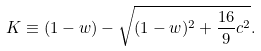<formula> <loc_0><loc_0><loc_500><loc_500>K \equiv ( 1 - w ) - \sqrt { ( 1 - w ) ^ { 2 } + \frac { 1 6 } { 9 } c ^ { 2 } } .</formula> 